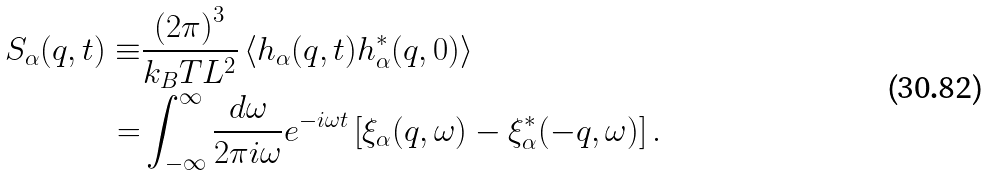Convert formula to latex. <formula><loc_0><loc_0><loc_500><loc_500>S _ { \alpha } ( q , t ) \equiv & \frac { \left ( 2 \pi \right ) ^ { 3 } } { k _ { B } T L ^ { 2 } } \left < h _ { \alpha } ( q , t ) h _ { \alpha } ^ { * } ( q , 0 ) \right > \\ = & \int _ { - \infty } ^ { \infty } \frac { d \omega } { 2 \pi i \omega } e ^ { - i \omega t } \left [ \xi _ { \alpha } ( q , \omega ) - \xi _ { \alpha } ^ { * } ( - q , \omega ) \right ] .</formula> 